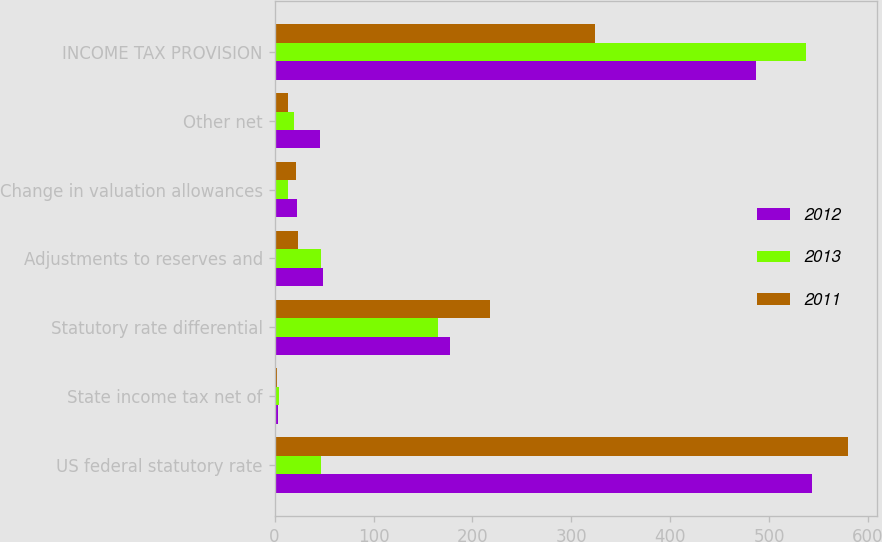<chart> <loc_0><loc_0><loc_500><loc_500><stacked_bar_chart><ecel><fcel>US federal statutory rate<fcel>State income tax net of<fcel>Statutory rate differential<fcel>Adjustments to reserves and<fcel>Change in valuation allowances<fcel>Other net<fcel>INCOME TAX PROVISION<nl><fcel>2012<fcel>543<fcel>3<fcel>177<fcel>49<fcel>23<fcel>46<fcel>487<nl><fcel>2013<fcel>46.5<fcel>4<fcel>165<fcel>47<fcel>14<fcel>20<fcel>537<nl><fcel>2011<fcel>580<fcel>2<fcel>218<fcel>24<fcel>22<fcel>14<fcel>324<nl></chart> 